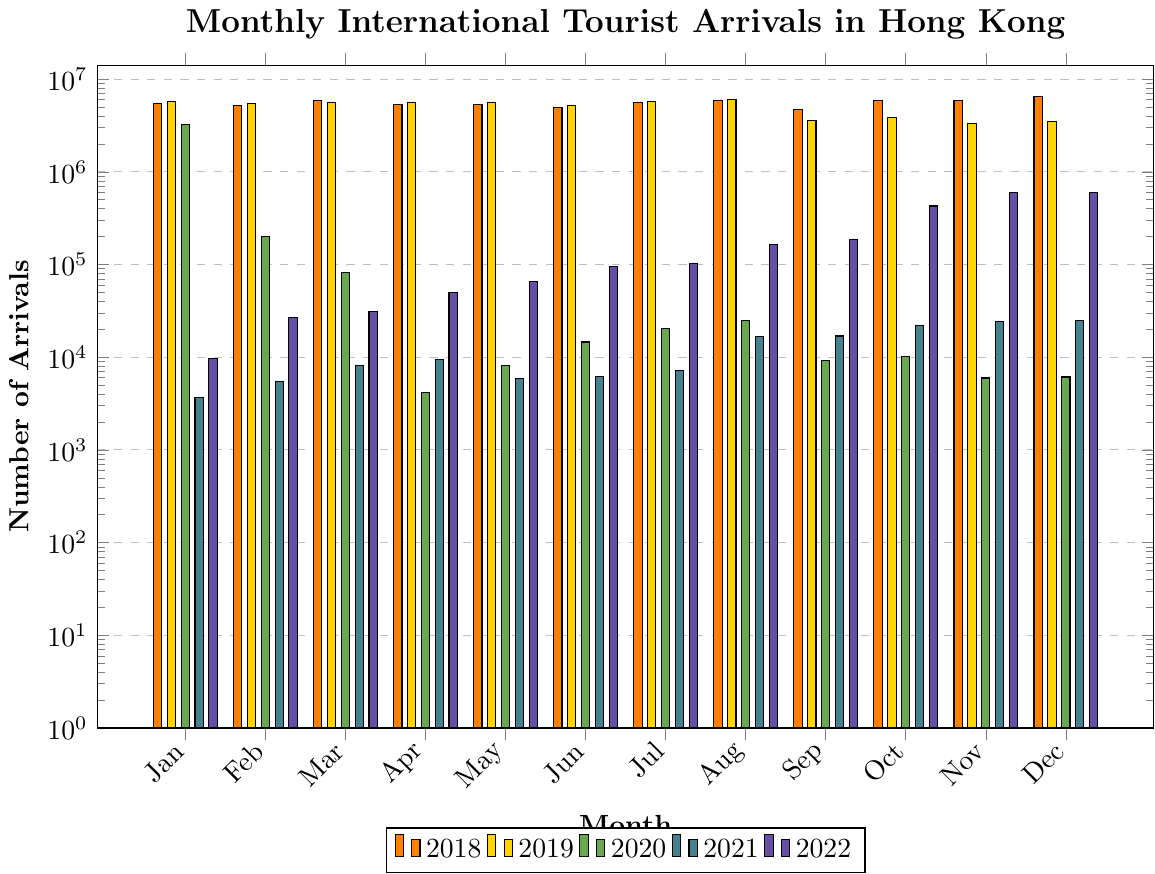What was the highest number of international tourist arrivals for any month in 2018? Look for the tallest bar in the 2018 series, which corresponds to December with a value of 6,465,315.
Answer: 6,465,315 How did tourist arrivals in October 2022 compare to October 2021? Observe the heights of the bars for October in the years 2022 and 2021. The bar for 2022 is significantly taller (427,340) than the bar for 2021 (21,778).
Answer: Higher in 2022 Which year had the lowest total tourist arrivals in February, and what was the number of arrivals? Look for the shortest bar in February across all years. The shortest bar is in 2021 with 5,421 arrivals.
Answer: 2021, 5,421 Was there any month in 2020 where international tourist arrivals were higher than in 2021 for the same month? Compare the heights of the bars for each month between 2020 and 2021. The only month where 2020’s bar is taller than 2021 is January (3,206,830 in 2020 vs 3,689 in 2021).
Answer: Yes, January Calculate the average number of tourist arrivals for the month of August over the 5-year period. Add the values for August in 2018 (5,882,587), 2019 (5,973,997), 2020 (24,889), 2021 (16,655), and 2022 (164,012). Divide the sum by 5. The sum is 12,062,140 and the average is 12,062,140 / 5 = 2,412,428.
Answer: 2,412,428 Which month showed the most dramatic decrease in tourist arrivals from 2019 to 2020? Calculate the difference for each month between 2019 and 2020, and identify the month with the largest difference. The largest drop is in February: 5,459,914 (2019) - 199,758 (2020) = 5,260,156.
Answer: February Did tourist arrivals in Hong Kong ever fully recover in any month of 2022 compared to 2018 levels? Compare each month’s bar heights in 2022 with the corresponding months in 2018. No month in 2022 reached or exceeded the levels seen in 2018.
Answer: No How did the total number of tourist arrivals in May 2022 compare to May 2020? Observe the heights of the bars for May in both years. May 2022 (65,862) is much taller than May 2020 (8,139).
Answer: Higher in 2022 What trend do you observe in the total tourist arrivals in the month of December from 2018 to 2022? Track the height of the bars for December across the years. The number declines sharply from 2018 (6,465,315) to 2019 (3,519,514) and remains low in 2020 (6,124) and 2021 (24,693), but increases significantly in 2022 (604,589).
Answer: Decrease then increase 